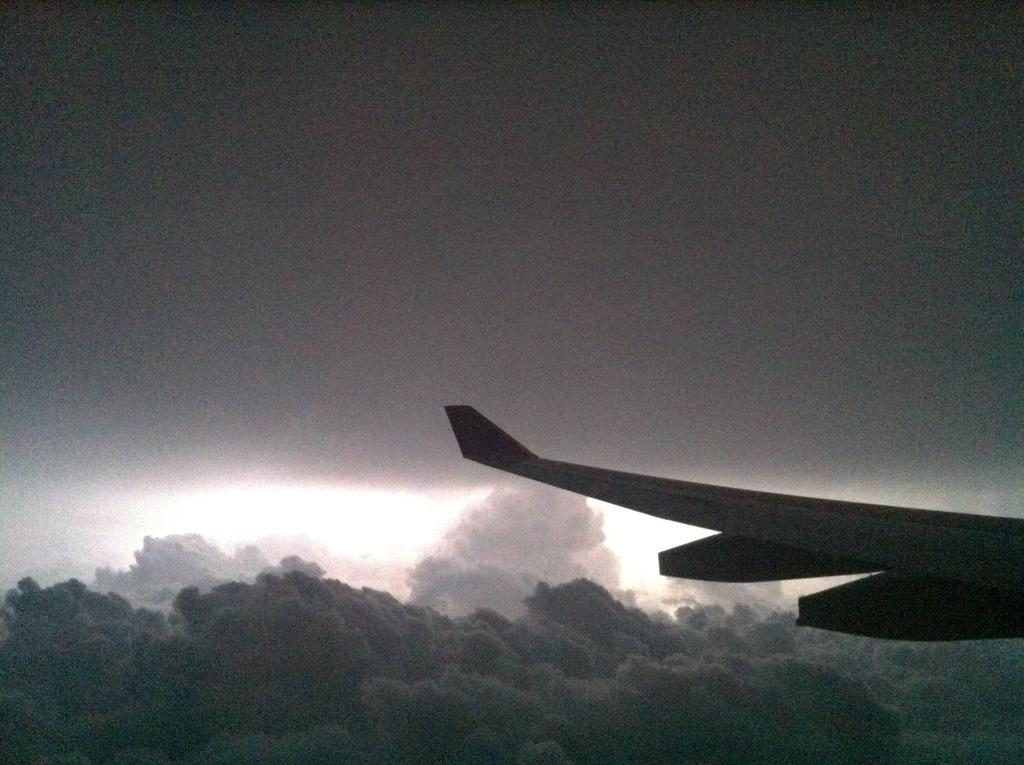What part of an airplane is visible in the image? There is a wing of an airplane in the image. What can be seen in the sky in the background of the image? There are clouds visible in the sky in the background of the image. What hobbies does the wing of the airplane have in the image? The wing of the airplane does not have any hobbies, as it is an inanimate object. 